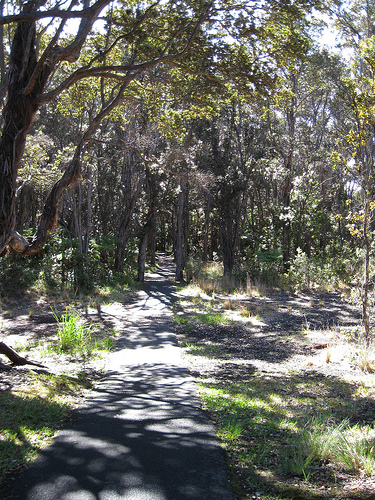<image>
Is there a tree shadow to the left of the path? No. The tree shadow is not to the left of the path. From this viewpoint, they have a different horizontal relationship. 